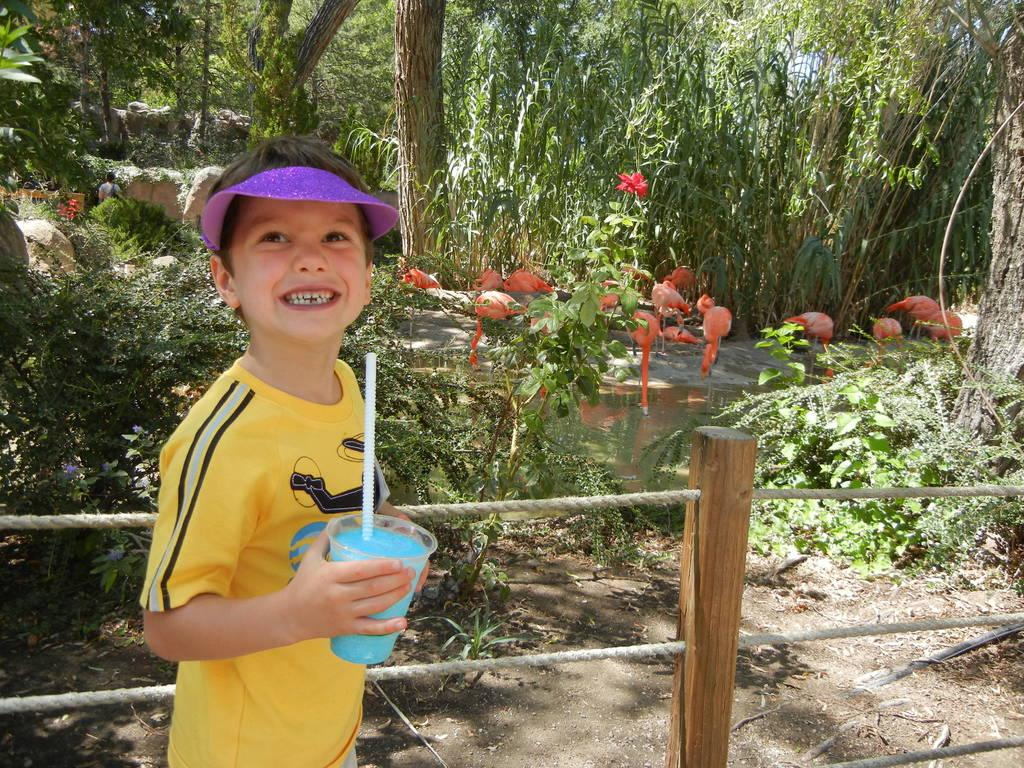Who is present in the image? There is a boy in the image. What is the boy doing in the image? The boy is standing beside a fence and smiling. What is the boy holding in his hand? The boy is holding a glass in his hand. What can be seen in the background of the image? There is water, plants, and trees visible in the background of the image. What type of glue is the boy using to stick the level to the fence in the image? There is no glue or level present in the image. The boy is simply standing beside a fence and holding a glass. 